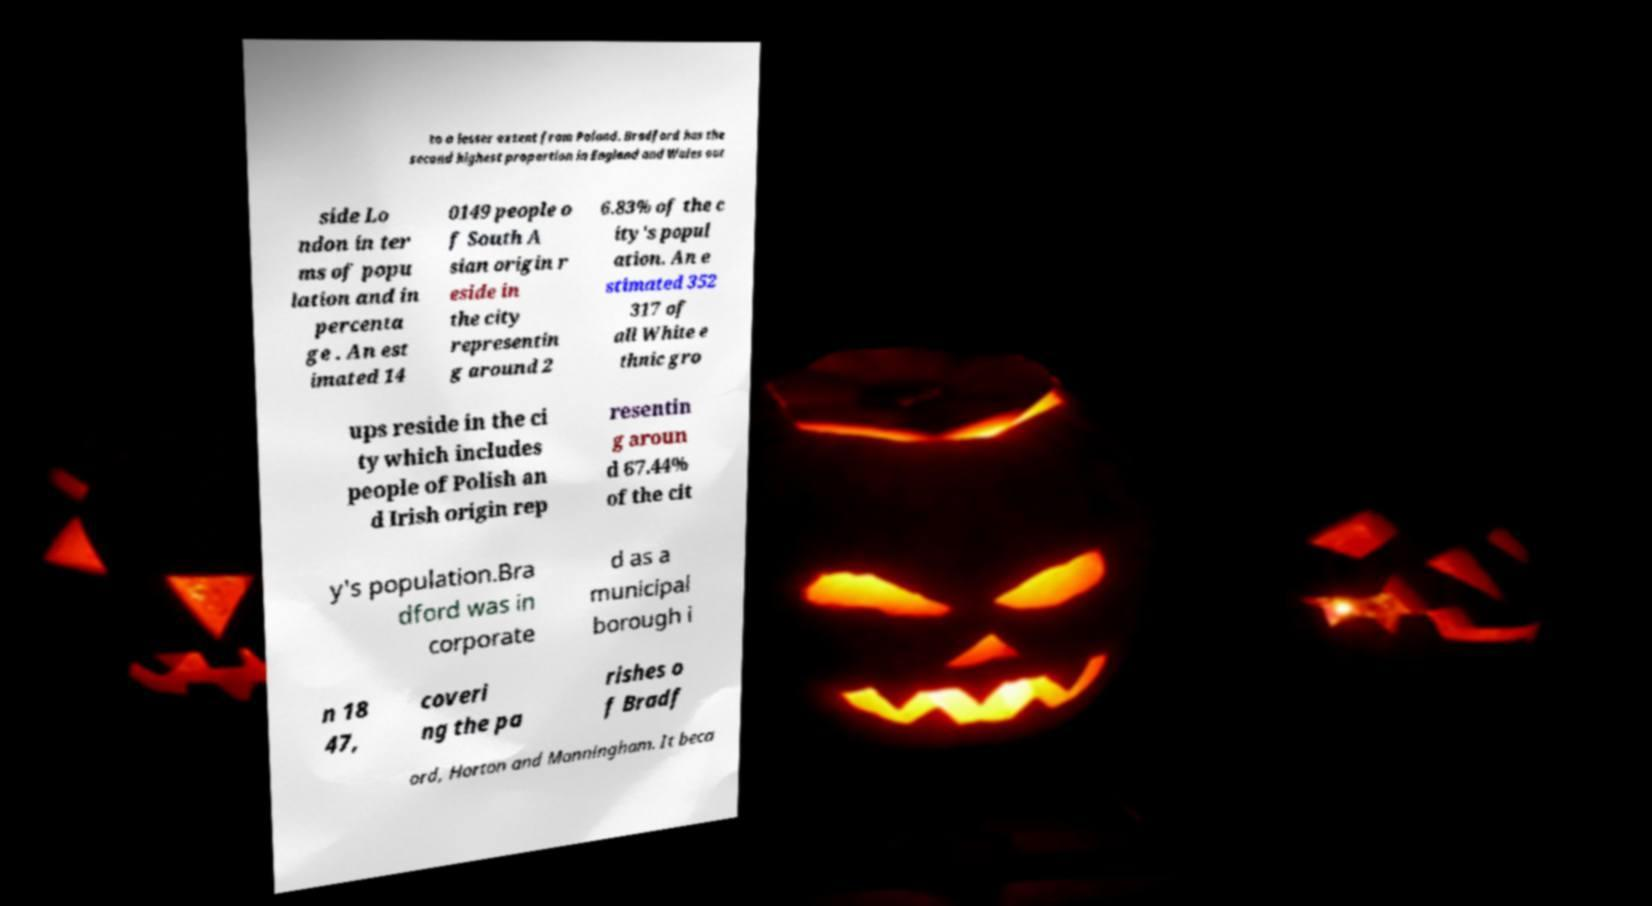What messages or text are displayed in this image? I need them in a readable, typed format. to a lesser extent from Poland. Bradford has the second highest proportion in England and Wales out side Lo ndon in ter ms of popu lation and in percenta ge . An est imated 14 0149 people o f South A sian origin r eside in the city representin g around 2 6.83% of the c ity's popul ation. An e stimated 352 317 of all White e thnic gro ups reside in the ci ty which includes people of Polish an d Irish origin rep resentin g aroun d 67.44% of the cit y's population.Bra dford was in corporate d as a municipal borough i n 18 47, coveri ng the pa rishes o f Bradf ord, Horton and Manningham. It beca 